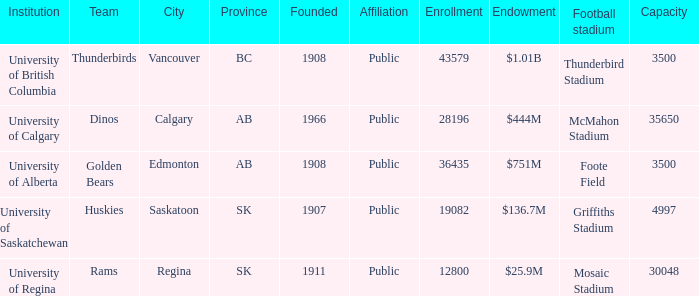Would you mind parsing the complete table? {'header': ['Institution', 'Team', 'City', 'Province', 'Founded', 'Affiliation', 'Enrollment', 'Endowment', 'Football stadium', 'Capacity'], 'rows': [['University of British Columbia', 'Thunderbirds', 'Vancouver', 'BC', '1908', 'Public', '43579', '$1.01B', 'Thunderbird Stadium', '3500'], ['University of Calgary', 'Dinos', 'Calgary', 'AB', '1966', 'Public', '28196', '$444M', 'McMahon Stadium', '35650'], ['University of Alberta', 'Golden Bears', 'Edmonton', 'AB', '1908', 'Public', '36435', '$751M', 'Foote Field', '3500'], ['University of Saskatchewan', 'Huskies', 'Saskatoon', 'SK', '1907', 'Public', '19082', '$136.7M', 'Griffiths Stadium', '4997'], ['University of Regina', 'Rams', 'Regina', 'SK', '1911', 'Public', '12800', '$25.9M', 'Mosaic Stadium', '30048']]} How many establishments are displayed for the football stadium of mosaic stadium? 1.0. 